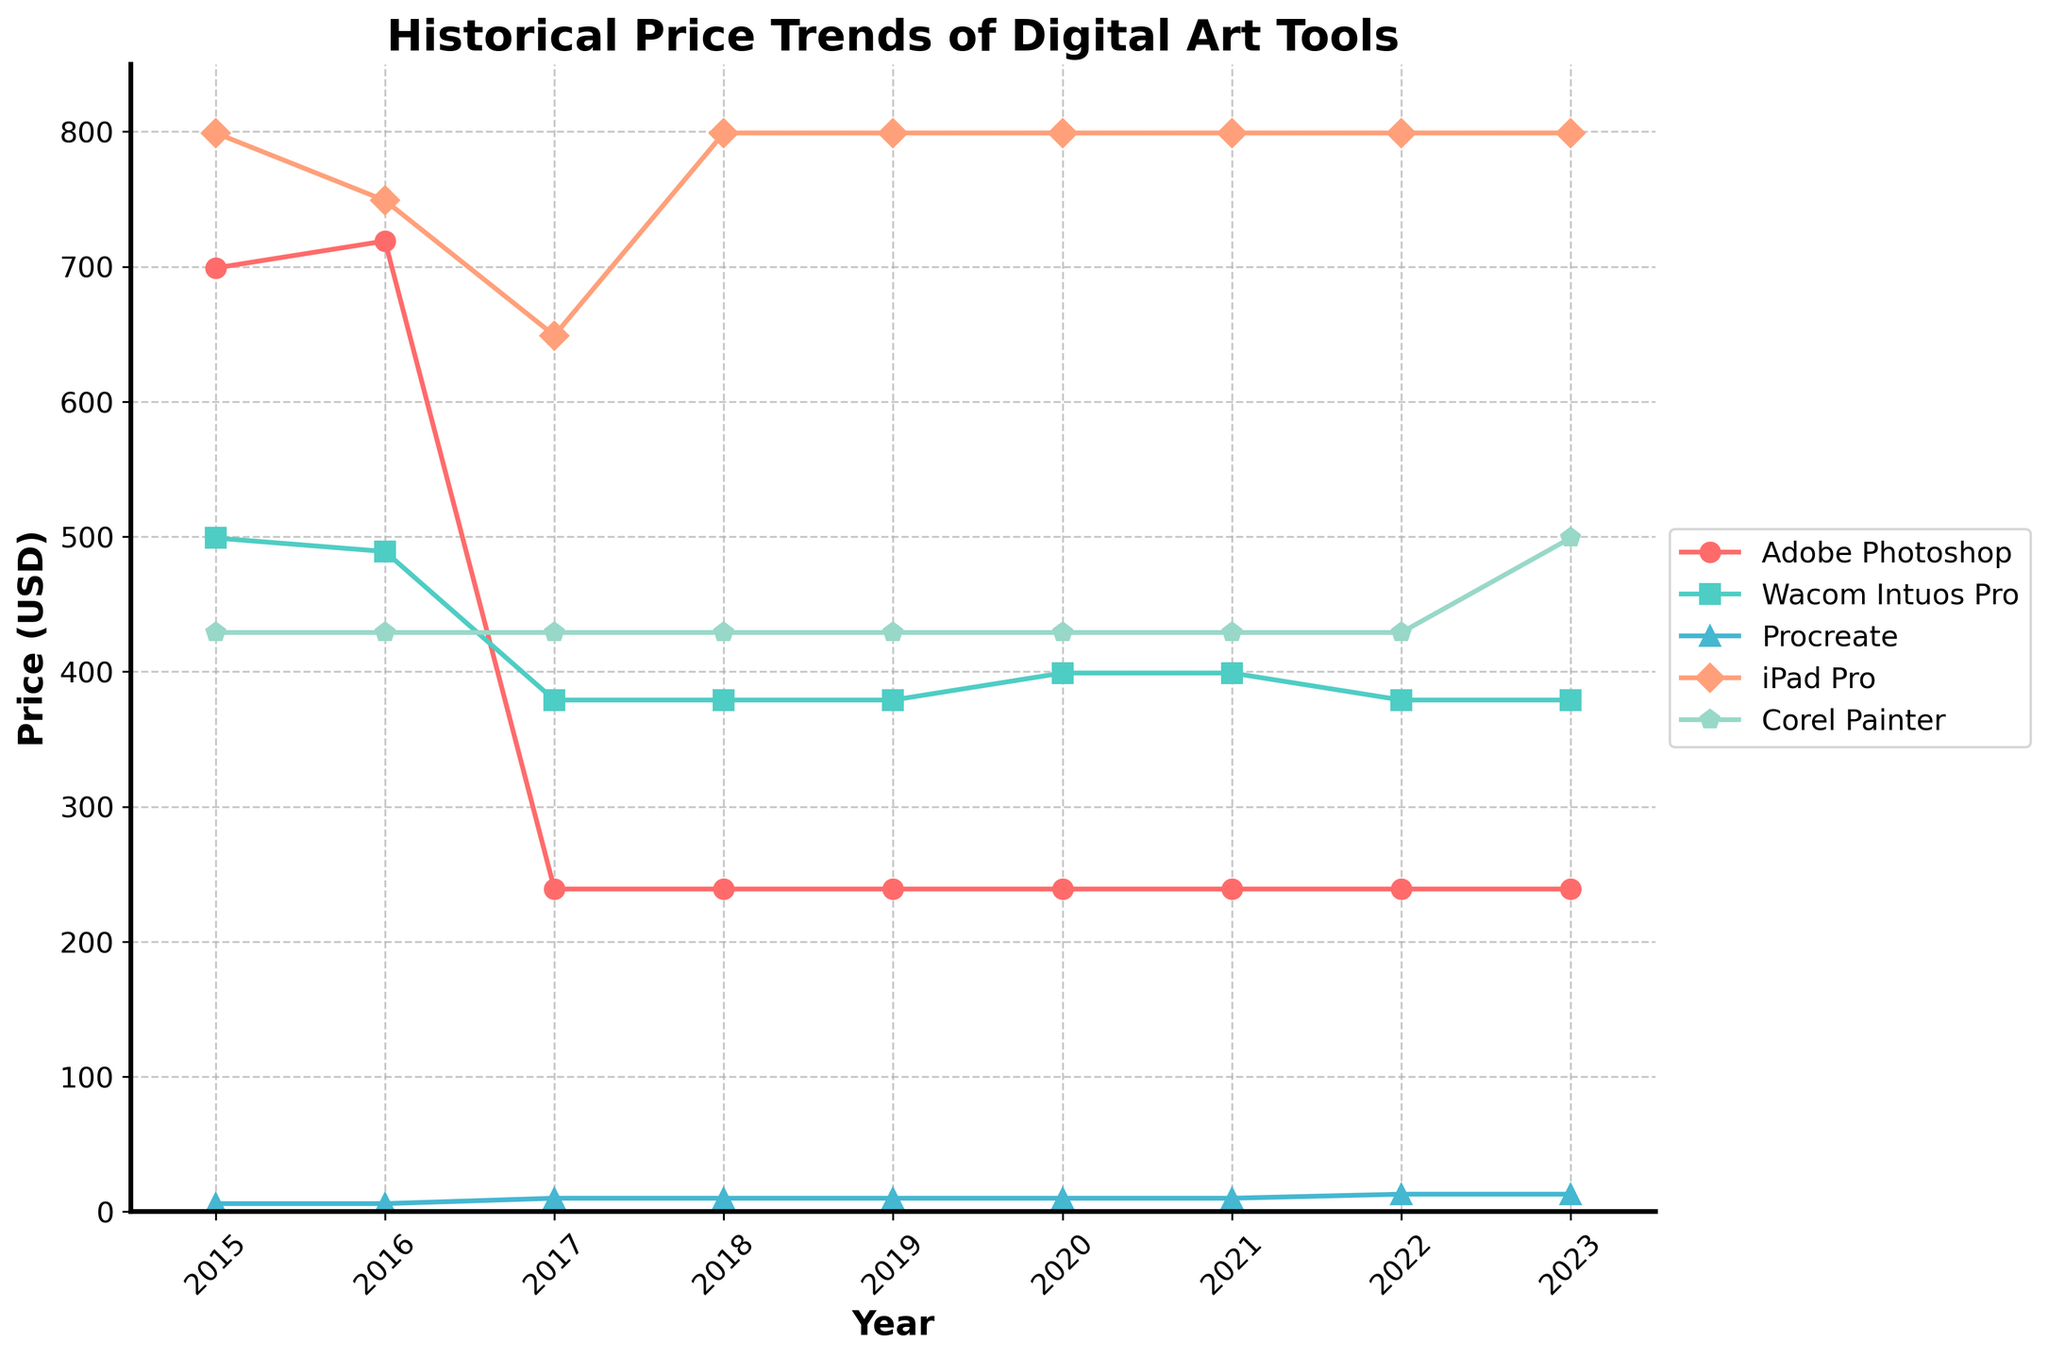What's the price of Adobe Photoshop in 2017? Look at the line corresponding to Adobe Photoshop and identify the price in the year 2017.
Answer: 239 In which year did the price of Procreate increase to $9.99? Follow the Procreate line and observe the price change.
Answer: 2017 Comparing the starting and ending prices, which tool had the biggest price increase? Identify the initial and final prices of each tool and calculate the difference. Compare these differences. Corel Painter: 429 to 499, Increase: 70
Answer: Corel Painter What was the price difference between the iPad Pro and Adobe Photoshop in 2019? Locate the prices of both iPad Pro and Adobe Photoshop for 2019 and subtract Photoshop’s price from iPad Pro’s price.
Answer: 560 Between which years did the Wacom Intuos Pro experience a price increase? Trace the Wacom Intuos Pro line and find the segments where the price increased.
Answer: 2019-2020 Which tool showed the most consistent pricing over the years? Examine each tool's price line for minimal fluctuation.
Answer: Corel Painter What was the average price of Adobe Photoshop from 2017 to 2023? Sum the prices of Adobe Photoshop from 2017 to 2023 and divide by the number of years (7).
Answer: 239 Which data point is represented by a triangle on the graph? Identify the marker shape for each category and trace the triangle shape to its corresponding data point.
Answer: Procreate If you were to subscribe to Procreate in 2022 and 2023, how much would you spend in total? Sum the prices of Procreate for 2022 and 2023.
Answer: 25.98 What year did the iPad Pro's price remain the same as in 2018? Look for a year when the iPad Pro's price equals that in 2018.
Answer: 2019-2022 